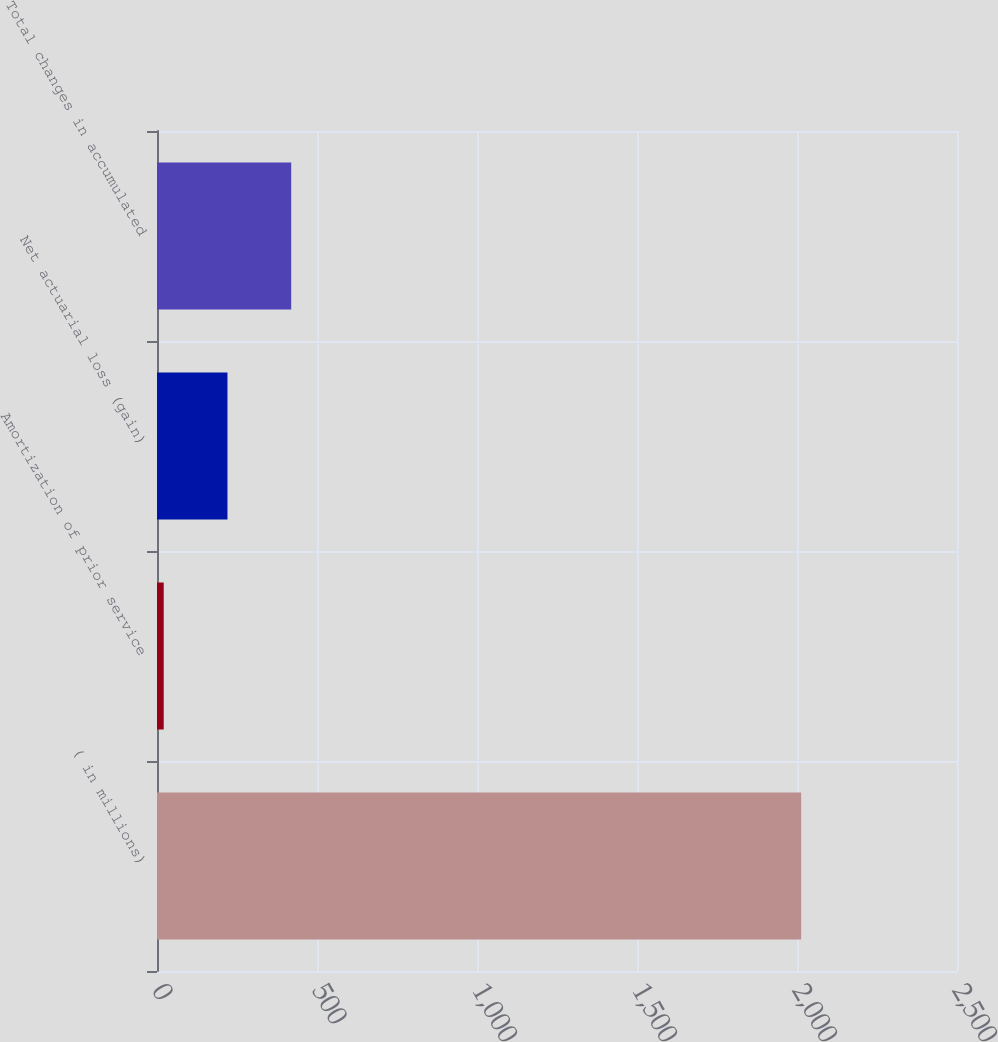<chart> <loc_0><loc_0><loc_500><loc_500><bar_chart><fcel>( in millions)<fcel>Amortization of prior service<fcel>Net actuarial loss (gain)<fcel>Total changes in accumulated<nl><fcel>2013<fcel>21<fcel>220.2<fcel>419.4<nl></chart> 